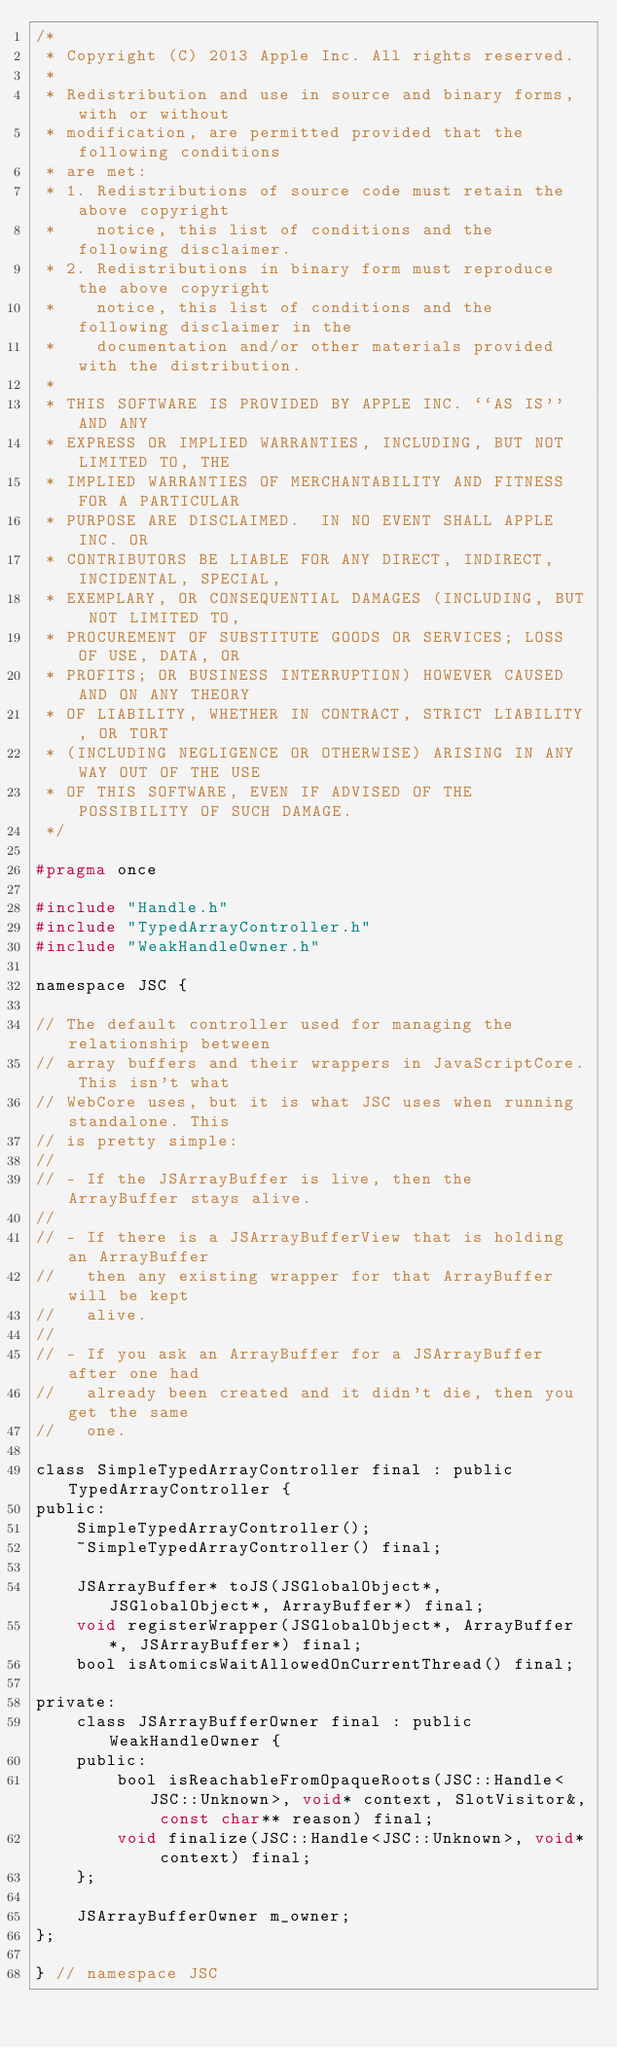Convert code to text. <code><loc_0><loc_0><loc_500><loc_500><_C_>/*
 * Copyright (C) 2013 Apple Inc. All rights reserved.
 *
 * Redistribution and use in source and binary forms, with or without
 * modification, are permitted provided that the following conditions
 * are met:
 * 1. Redistributions of source code must retain the above copyright
 *    notice, this list of conditions and the following disclaimer.
 * 2. Redistributions in binary form must reproduce the above copyright
 *    notice, this list of conditions and the following disclaimer in the
 *    documentation and/or other materials provided with the distribution.
 *
 * THIS SOFTWARE IS PROVIDED BY APPLE INC. ``AS IS'' AND ANY
 * EXPRESS OR IMPLIED WARRANTIES, INCLUDING, BUT NOT LIMITED TO, THE
 * IMPLIED WARRANTIES OF MERCHANTABILITY AND FITNESS FOR A PARTICULAR
 * PURPOSE ARE DISCLAIMED.  IN NO EVENT SHALL APPLE INC. OR
 * CONTRIBUTORS BE LIABLE FOR ANY DIRECT, INDIRECT, INCIDENTAL, SPECIAL,
 * EXEMPLARY, OR CONSEQUENTIAL DAMAGES (INCLUDING, BUT NOT LIMITED TO,
 * PROCUREMENT OF SUBSTITUTE GOODS OR SERVICES; LOSS OF USE, DATA, OR
 * PROFITS; OR BUSINESS INTERRUPTION) HOWEVER CAUSED AND ON ANY THEORY
 * OF LIABILITY, WHETHER IN CONTRACT, STRICT LIABILITY, OR TORT
 * (INCLUDING NEGLIGENCE OR OTHERWISE) ARISING IN ANY WAY OUT OF THE USE
 * OF THIS SOFTWARE, EVEN IF ADVISED OF THE POSSIBILITY OF SUCH DAMAGE. 
 */

#pragma once

#include "Handle.h"
#include "TypedArrayController.h"
#include "WeakHandleOwner.h"

namespace JSC {

// The default controller used for managing the relationship between
// array buffers and their wrappers in JavaScriptCore. This isn't what
// WebCore uses, but it is what JSC uses when running standalone. This
// is pretty simple:
//
// - If the JSArrayBuffer is live, then the ArrayBuffer stays alive.
//
// - If there is a JSArrayBufferView that is holding an ArrayBuffer
//   then any existing wrapper for that ArrayBuffer will be kept
//   alive.
//
// - If you ask an ArrayBuffer for a JSArrayBuffer after one had
//   already been created and it didn't die, then you get the same
//   one.

class SimpleTypedArrayController final : public TypedArrayController {
public:
    SimpleTypedArrayController();
    ~SimpleTypedArrayController() final;
    
    JSArrayBuffer* toJS(JSGlobalObject*, JSGlobalObject*, ArrayBuffer*) final;
    void registerWrapper(JSGlobalObject*, ArrayBuffer*, JSArrayBuffer*) final;
    bool isAtomicsWaitAllowedOnCurrentThread() final;

private:
    class JSArrayBufferOwner final : public WeakHandleOwner {
    public:
        bool isReachableFromOpaqueRoots(JSC::Handle<JSC::Unknown>, void* context, SlotVisitor&, const char** reason) final;
        void finalize(JSC::Handle<JSC::Unknown>, void* context) final;
    };

    JSArrayBufferOwner m_owner;
};

} // namespace JSC
</code> 